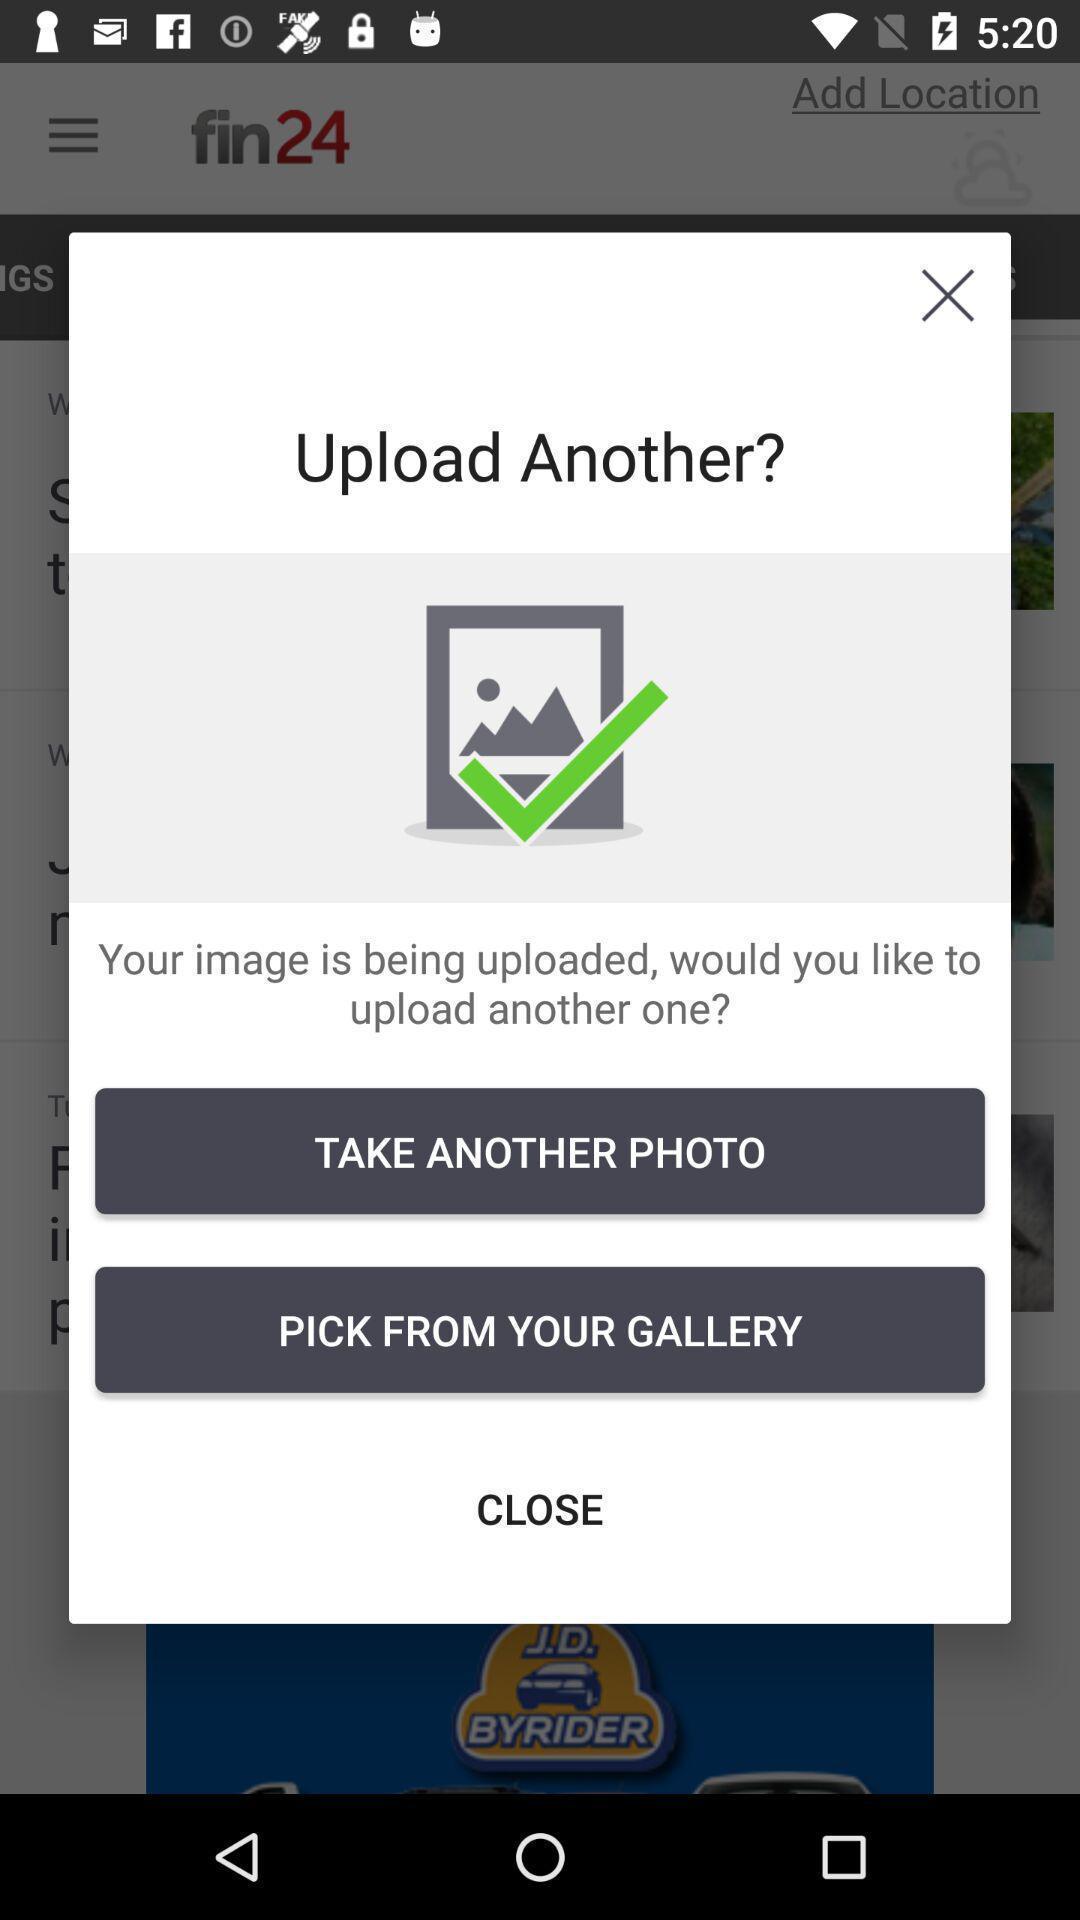Give me a summary of this screen capture. Pop-up showing upload status of an image and other options. 